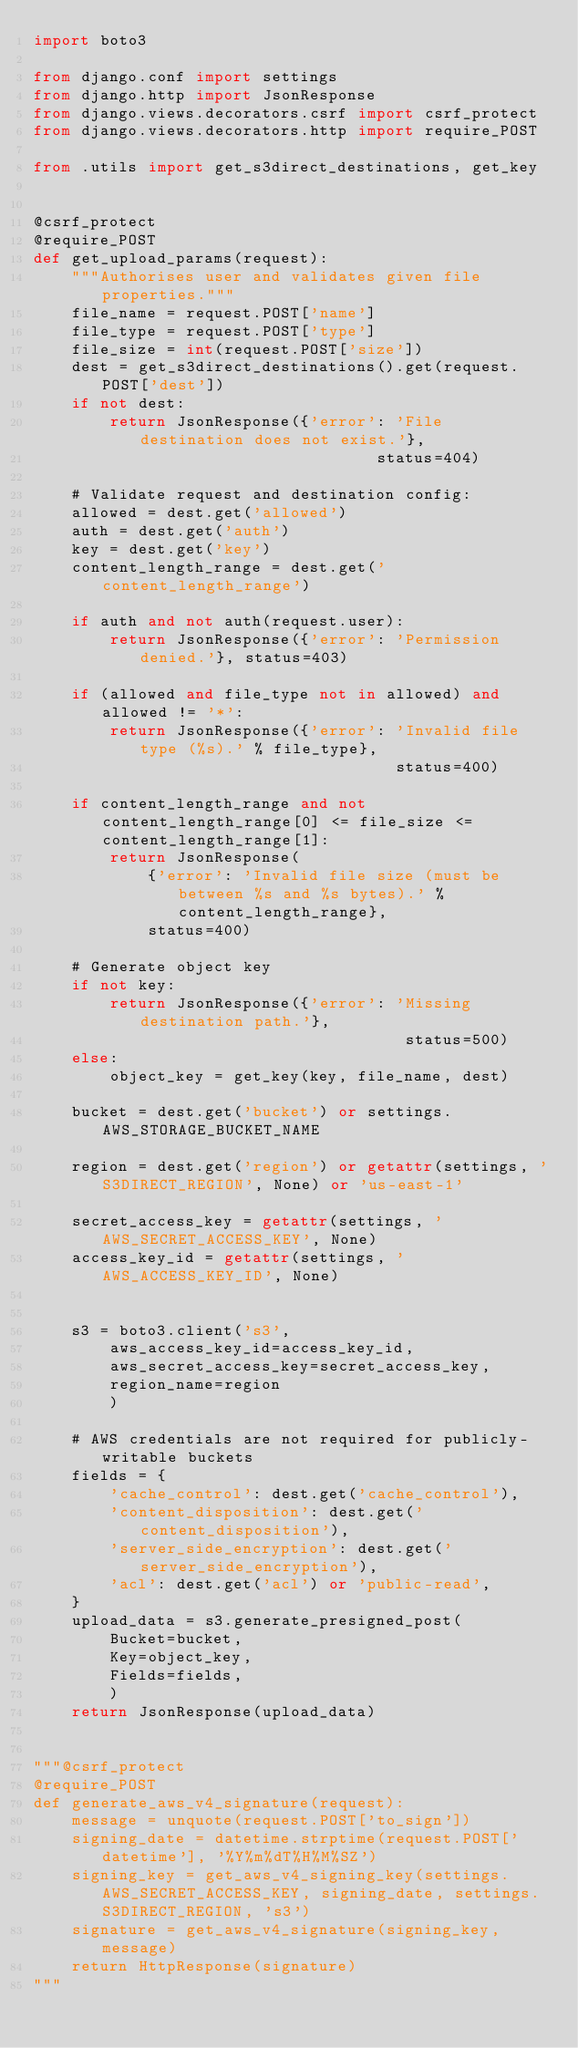<code> <loc_0><loc_0><loc_500><loc_500><_Python_>import boto3

from django.conf import settings
from django.http import JsonResponse
from django.views.decorators.csrf import csrf_protect
from django.views.decorators.http import require_POST

from .utils import get_s3direct_destinations, get_key


@csrf_protect
@require_POST
def get_upload_params(request):
    """Authorises user and validates given file properties."""
    file_name = request.POST['name']
    file_type = request.POST['type']
    file_size = int(request.POST['size'])
    dest = get_s3direct_destinations().get(request.POST['dest'])
    if not dest:
        return JsonResponse({'error': 'File destination does not exist.'},
                                    status=404)

    # Validate request and destination config:
    allowed = dest.get('allowed')
    auth = dest.get('auth')
    key = dest.get('key')
    content_length_range = dest.get('content_length_range')

    if auth and not auth(request.user):
        return JsonResponse({'error': 'Permission denied.'}, status=403)

    if (allowed and file_type not in allowed) and allowed != '*':
        return JsonResponse({'error': 'Invalid file type (%s).' % file_type},
                                      status=400)

    if content_length_range and not content_length_range[0] <= file_size <= content_length_range[1]:
        return JsonResponse(
            {'error': 'Invalid file size (must be between %s and %s bytes).' % content_length_range},
            status=400)

    # Generate object key
    if not key:
        return JsonResponse({'error': 'Missing destination path.'},
                                       status=500)
    else:
        object_key = get_key(key, file_name, dest)

    bucket = dest.get('bucket') or settings.AWS_STORAGE_BUCKET_NAME

    region = dest.get('region') or getattr(settings, 'S3DIRECT_REGION', None) or 'us-east-1'

    secret_access_key = getattr(settings, 'AWS_SECRET_ACCESS_KEY', None)
    access_key_id = getattr(settings, 'AWS_ACCESS_KEY_ID', None)


    s3 = boto3.client('s3',
        aws_access_key_id=access_key_id,
        aws_secret_access_key=secret_access_key,
        region_name=region
        )

    # AWS credentials are not required for publicly-writable buckets
    fields = {
        'cache_control': dest.get('cache_control'),
        'content_disposition': dest.get('content_disposition'),
        'server_side_encryption': dest.get('server_side_encryption'),
        'acl': dest.get('acl') or 'public-read',
    }
    upload_data = s3.generate_presigned_post(
        Bucket=bucket,
        Key=object_key,
        Fields=fields,
        )
    return JsonResponse(upload_data)


"""@csrf_protect
@require_POST
def generate_aws_v4_signature(request):
    message = unquote(request.POST['to_sign'])
    signing_date = datetime.strptime(request.POST['datetime'], '%Y%m%dT%H%M%SZ')
    signing_key = get_aws_v4_signing_key(settings.AWS_SECRET_ACCESS_KEY, signing_date, settings.S3DIRECT_REGION, 's3')
    signature = get_aws_v4_signature(signing_key, message)
    return HttpResponse(signature)
"""
</code> 